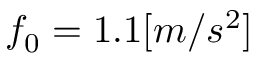Convert formula to latex. <formula><loc_0><loc_0><loc_500><loc_500>f _ { 0 } = 1 . 1 [ m / s ^ { 2 } ]</formula> 